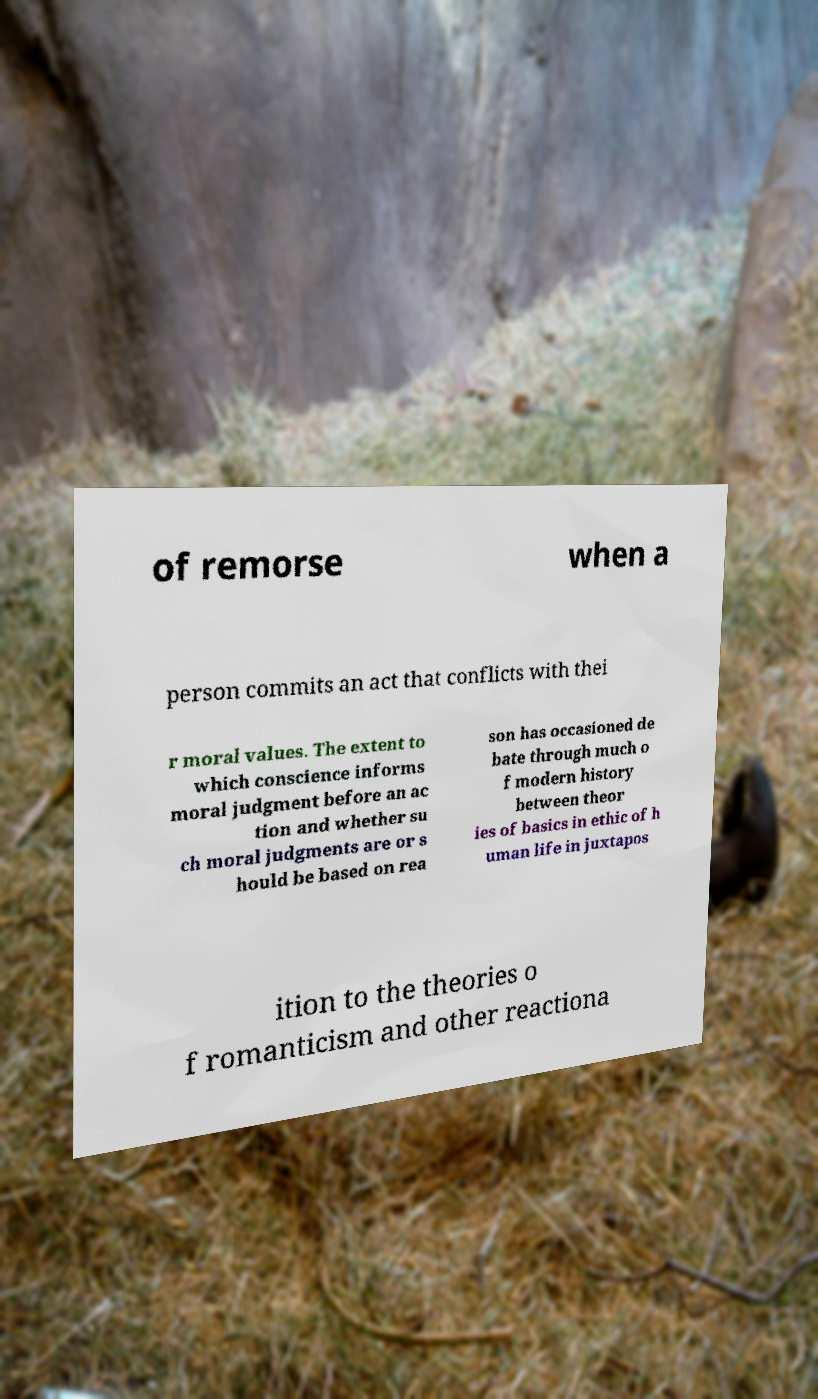Can you accurately transcribe the text from the provided image for me? of remorse when a person commits an act that conflicts with thei r moral values. The extent to which conscience informs moral judgment before an ac tion and whether su ch moral judgments are or s hould be based on rea son has occasioned de bate through much o f modern history between theor ies of basics in ethic of h uman life in juxtapos ition to the theories o f romanticism and other reactiona 